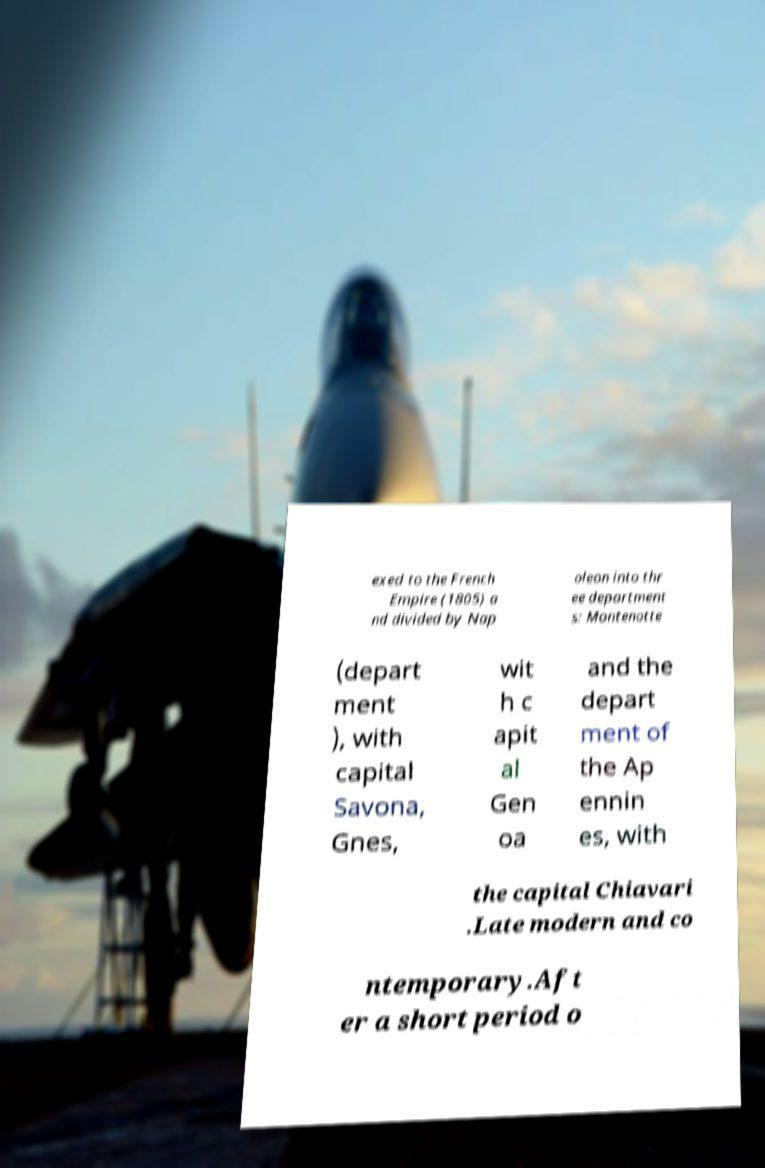What messages or text are displayed in this image? I need them in a readable, typed format. exed to the French Empire (1805) a nd divided by Nap oleon into thr ee department s: Montenotte (depart ment ), with capital Savona, Gnes, wit h c apit al Gen oa and the depart ment of the Ap ennin es, with the capital Chiavari .Late modern and co ntemporary.Aft er a short period o 